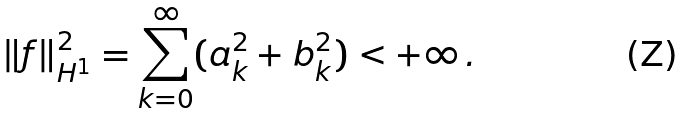Convert formula to latex. <formula><loc_0><loc_0><loc_500><loc_500>\| f \| ^ { 2 } _ { H ^ { 1 } } = \sum _ { k = 0 } ^ { \infty } ( a _ { k } ^ { 2 } + b _ { k } ^ { 2 } ) < + \infty \, .</formula> 